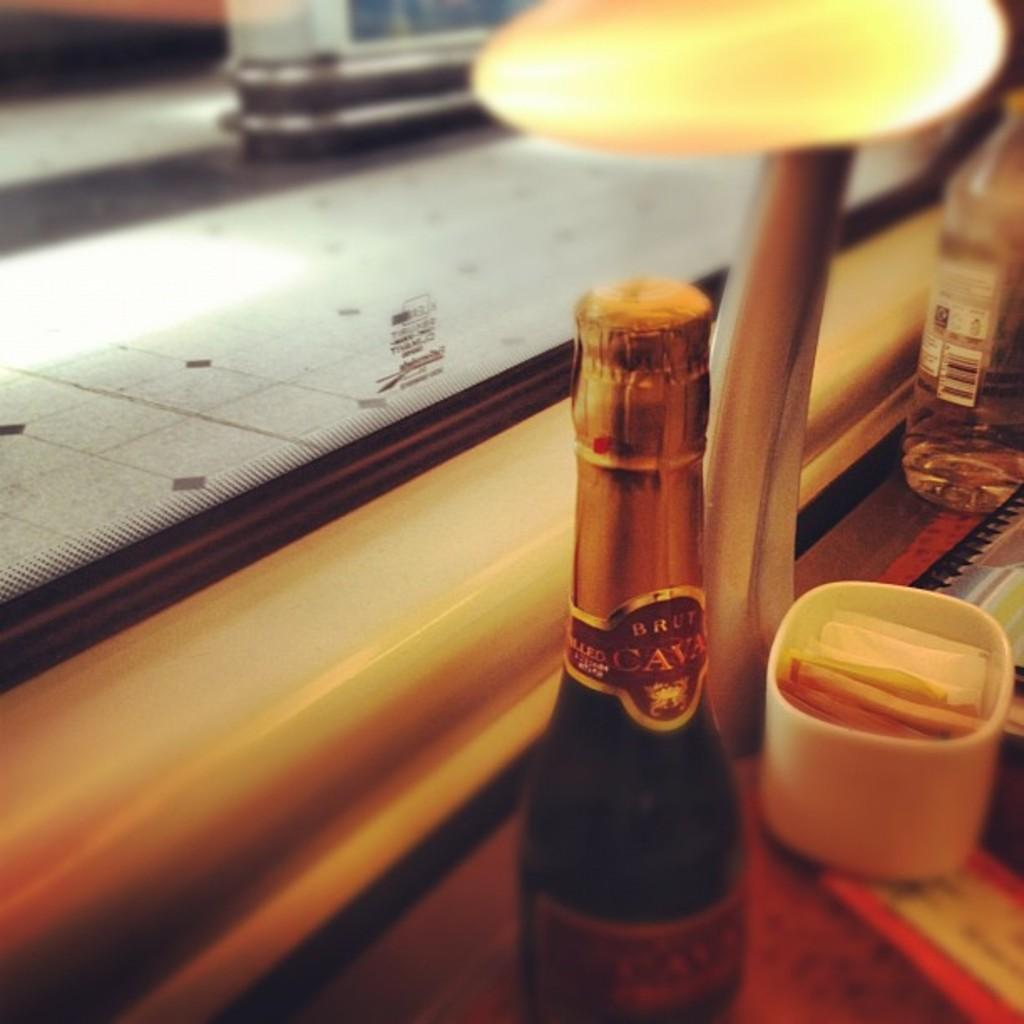<image>
Render a clear and concise summary of the photo. A closed bottle of Brut Cava Champagne with a gold cap. 